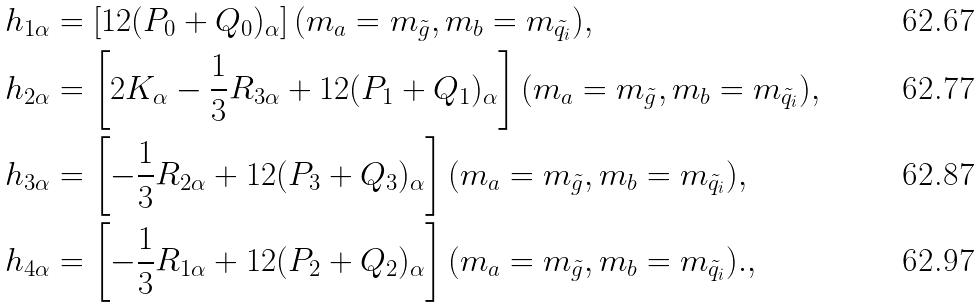Convert formula to latex. <formula><loc_0><loc_0><loc_500><loc_500>& h _ { 1 \alpha } = \left [ 1 2 ( P _ { 0 } + Q _ { 0 } ) _ { \alpha } \right ] ( m _ { a } = m _ { \tilde { g } } , m _ { b } = m _ { \tilde { q } _ { i } } ) , \\ & h _ { 2 \alpha } = \left [ 2 K _ { \alpha } - \frac { 1 } { 3 } R _ { 3 \alpha } + 1 2 ( P _ { 1 } + Q _ { 1 } ) _ { \alpha } \right ] ( m _ { a } = m _ { \tilde { g } } , m _ { b } = m _ { \tilde { q } _ { i } } ) , \\ & h _ { 3 \alpha } = \left [ - \frac { 1 } { 3 } R _ { 2 \alpha } + 1 2 ( P _ { 3 } + Q _ { 3 } ) _ { \alpha } \right ] ( m _ { a } = m _ { \tilde { g } } , m _ { b } = m _ { \tilde { q } _ { i } } ) , \\ & h _ { 4 \alpha } = \left [ - \frac { 1 } { 3 } R _ { 1 \alpha } + 1 2 ( P _ { 2 } + Q _ { 2 } ) _ { \alpha } \right ] ( m _ { a } = m _ { \tilde { g } } , m _ { b } = m _ { \tilde { q } _ { i } } ) . ,</formula> 